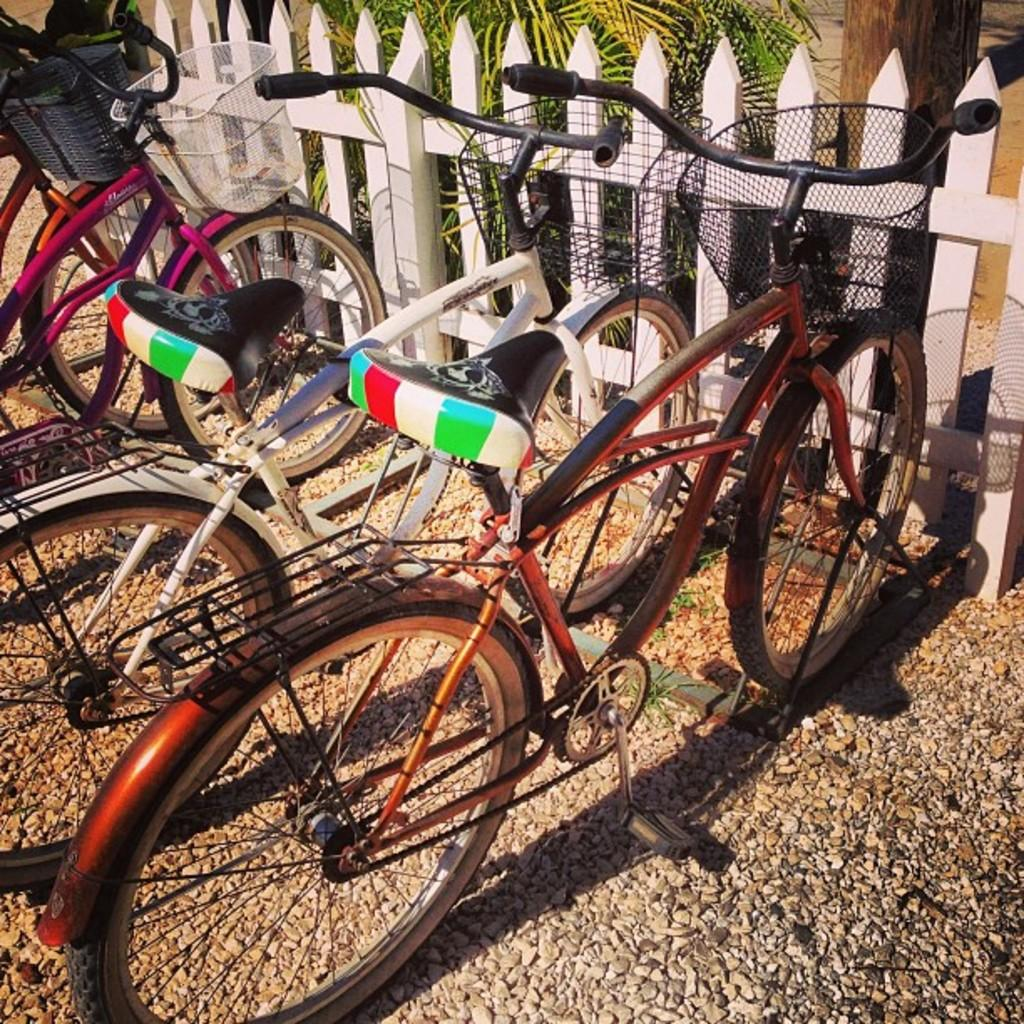What type of vehicles are in the image? There are bicycles in the image. What are the bicycles equipped with? There are baskets in the image. What type of natural elements are present in the image? There are stones and plants in the image. What type of architectural feature is in the image? There is a wooden railing in the image. What type of natural object is in the image? There is a branch in the image. What type of fuel is being used by the bicycles in the image? Bicycles do not use fuel; they are powered by the rider's pedaling. What type of crate is being used to transport the plants in the image? There is no crate present in the image; the plants are not being transported. 